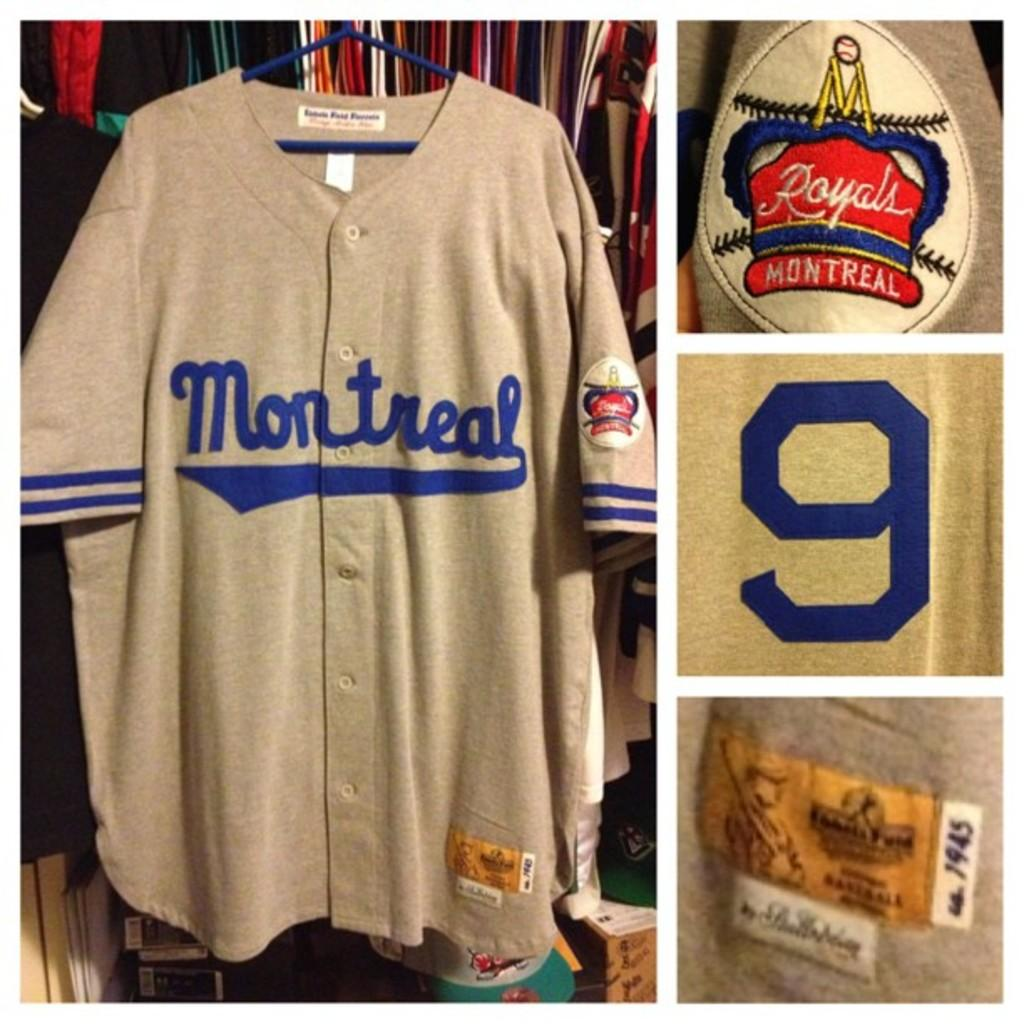Provide a one-sentence caption for the provided image. An authentic Baseball jersey says Montreal on it and has the number 9 on its sleeve. 